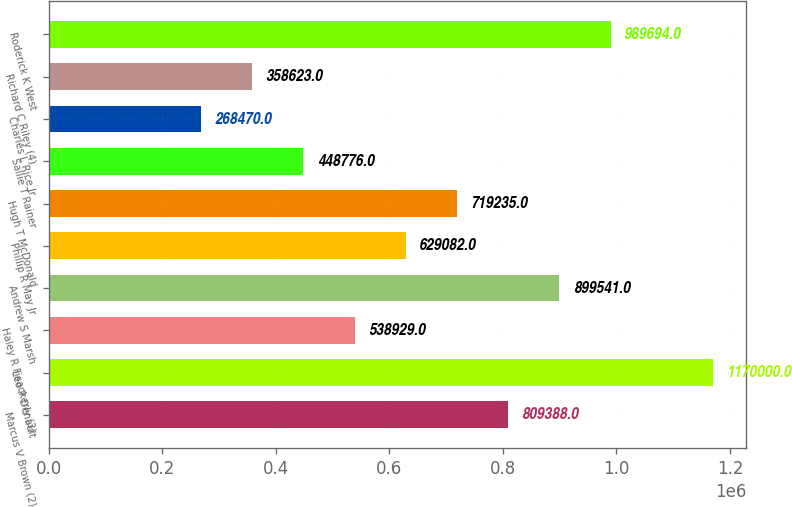Convert chart to OTSL. <chart><loc_0><loc_0><loc_500><loc_500><bar_chart><fcel>Marcus V Brown (2)<fcel>Leo P Denault<fcel>Haley R Fisackerly (3)<fcel>Andrew S Marsh<fcel>Phillip R May Jr<fcel>Hugh T McDonald<fcel>Sallie T Rainer<fcel>Charles L Rice Jr<fcel>Richard C Riley (4)<fcel>Roderick K West<nl><fcel>809388<fcel>1.17e+06<fcel>538929<fcel>899541<fcel>629082<fcel>719235<fcel>448776<fcel>268470<fcel>358623<fcel>989694<nl></chart> 